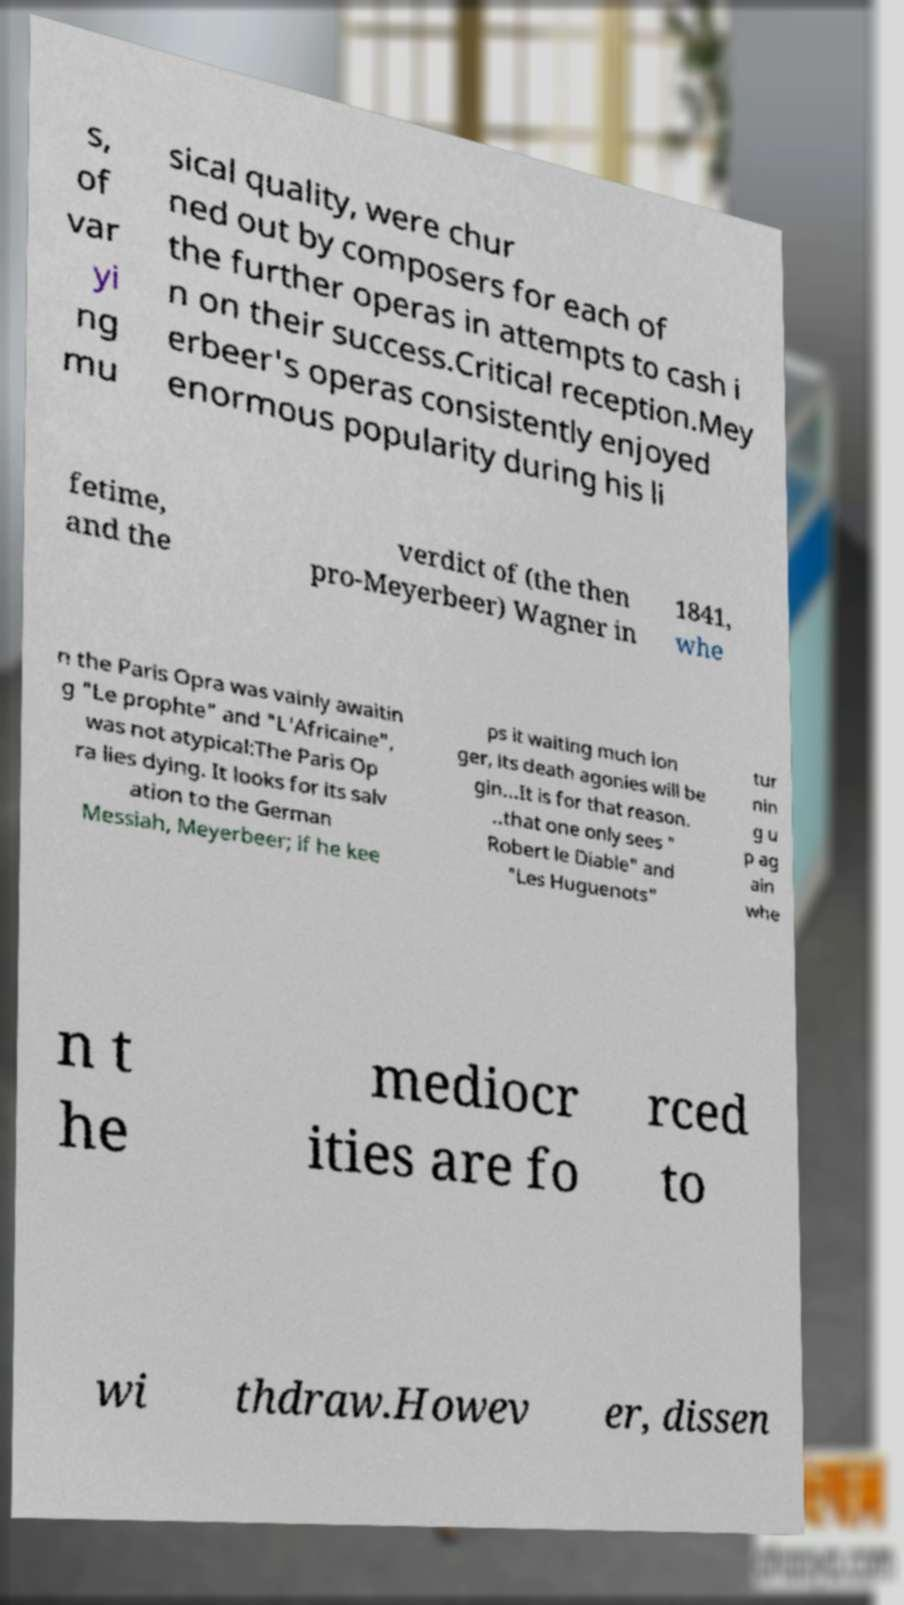Can you read and provide the text displayed in the image?This photo seems to have some interesting text. Can you extract and type it out for me? s, of var yi ng mu sical quality, were chur ned out by composers for each of the further operas in attempts to cash i n on their success.Critical reception.Mey erbeer's operas consistently enjoyed enormous popularity during his li fetime, and the verdict of (the then pro-Meyerbeer) Wagner in 1841, whe n the Paris Opra was vainly awaitin g "Le prophte" and "L'Africaine", was not atypical:The Paris Op ra lies dying. It looks for its salv ation to the German Messiah, Meyerbeer; if he kee ps it waiting much lon ger, its death agonies will be gin...It is for that reason. ..that one only sees " Robert le Diable" and "Les Huguenots" tur nin g u p ag ain whe n t he mediocr ities are fo rced to wi thdraw.Howev er, dissen 